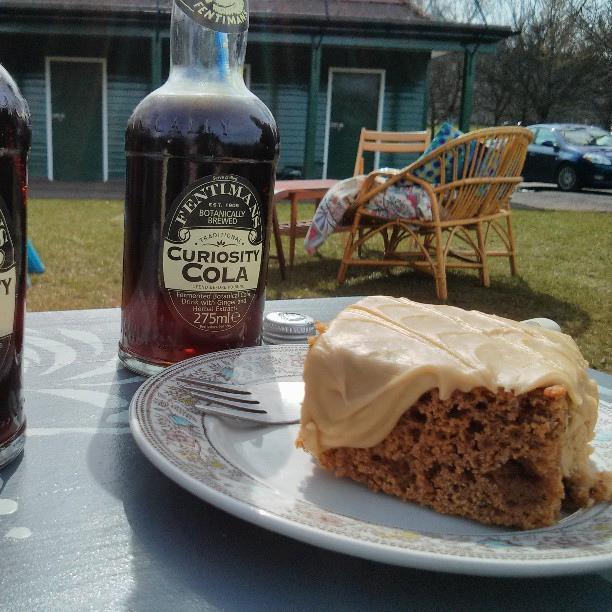What is the fork next to?
Answer the question by selecting the correct answer among the 4 following choices.
Options: Chili, cherry pie, cake, steak. Cake. 